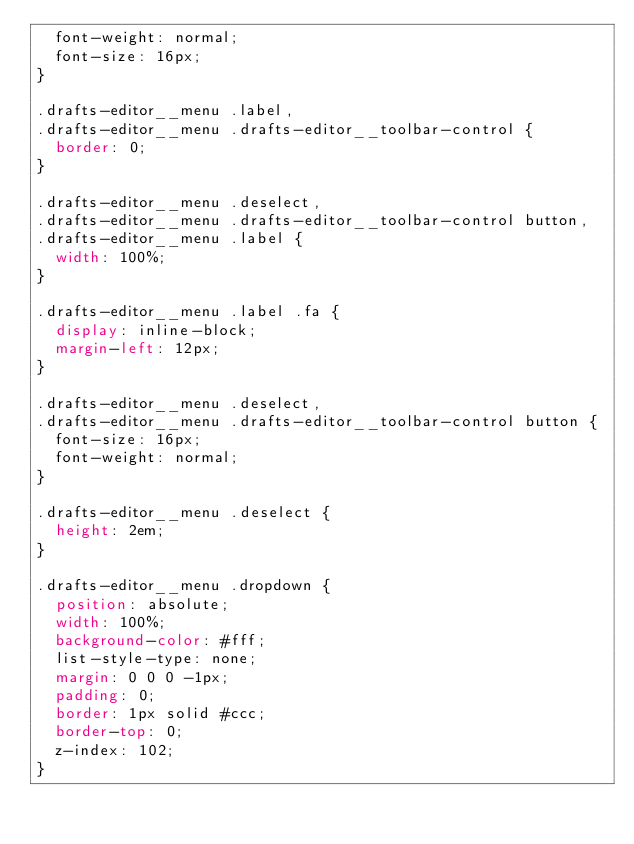<code> <loc_0><loc_0><loc_500><loc_500><_CSS_>  font-weight: normal;
  font-size: 16px;
}

.drafts-editor__menu .label,
.drafts-editor__menu .drafts-editor__toolbar-control {
  border: 0;
}

.drafts-editor__menu .deselect,
.drafts-editor__menu .drafts-editor__toolbar-control button,
.drafts-editor__menu .label {
  width: 100%;
}

.drafts-editor__menu .label .fa {
  display: inline-block;
  margin-left: 12px;
}

.drafts-editor__menu .deselect,
.drafts-editor__menu .drafts-editor__toolbar-control button {
  font-size: 16px;
  font-weight: normal;
}

.drafts-editor__menu .deselect {
  height: 2em;
}

.drafts-editor__menu .dropdown {
  position: absolute;
  width: 100%;
  background-color: #fff;
  list-style-type: none;
  margin: 0 0 0 -1px;
  padding: 0;
  border: 1px solid #ccc;
  border-top: 0;
  z-index: 102;
}
</code> 